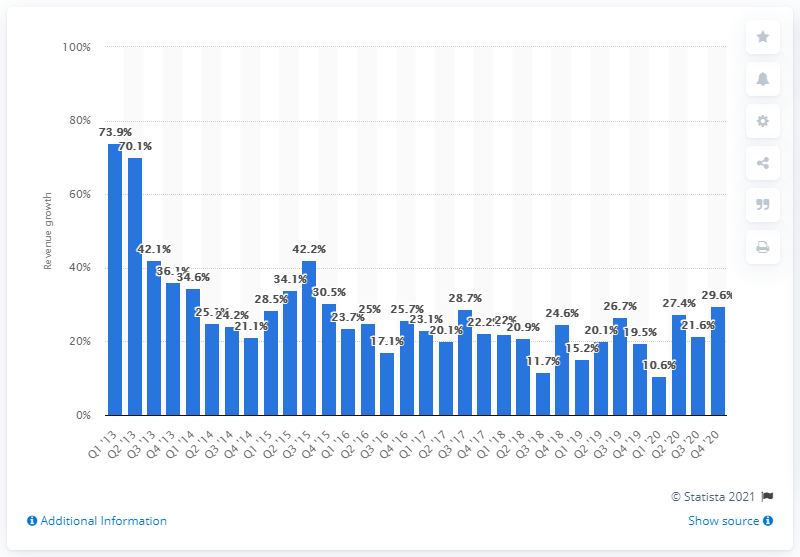Point out several critical features in this image. Zalando's revenue increased by 29.6% from the first quarter of 2013 to the last quarter of 2020. 